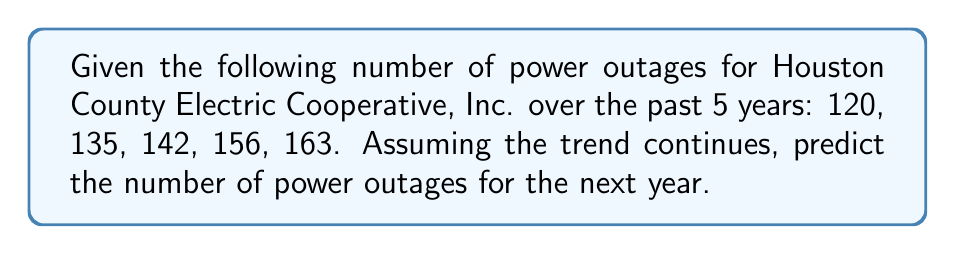What is the answer to this math problem? To predict the number of power outages for the next year based on historical data, we can use the arithmetic sequence approach:

1. Calculate the average increase per year:
   $\frac{163 - 120}{5 - 1} = \frac{43}{4} = 10.75$

2. Round to the nearest whole number as we're dealing with power outages:
   Average increase ≈ 11 outages per year

3. To predict the next year's outages, add 11 to the last year's number:
   $163 + 11 = 174$

Therefore, based on the historical trend, we can predict approximately 174 power outages for the next year.
Answer: 174 power outages 